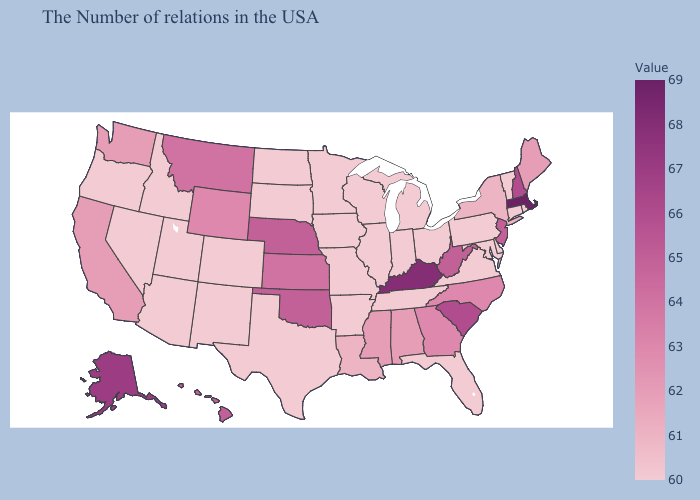Does Georgia have the lowest value in the USA?
Be succinct. No. Among the states that border West Virginia , does Maryland have the highest value?
Concise answer only. No. Does the map have missing data?
Quick response, please. No. Does Massachusetts have the highest value in the USA?
Concise answer only. Yes. Does the map have missing data?
Give a very brief answer. No. 